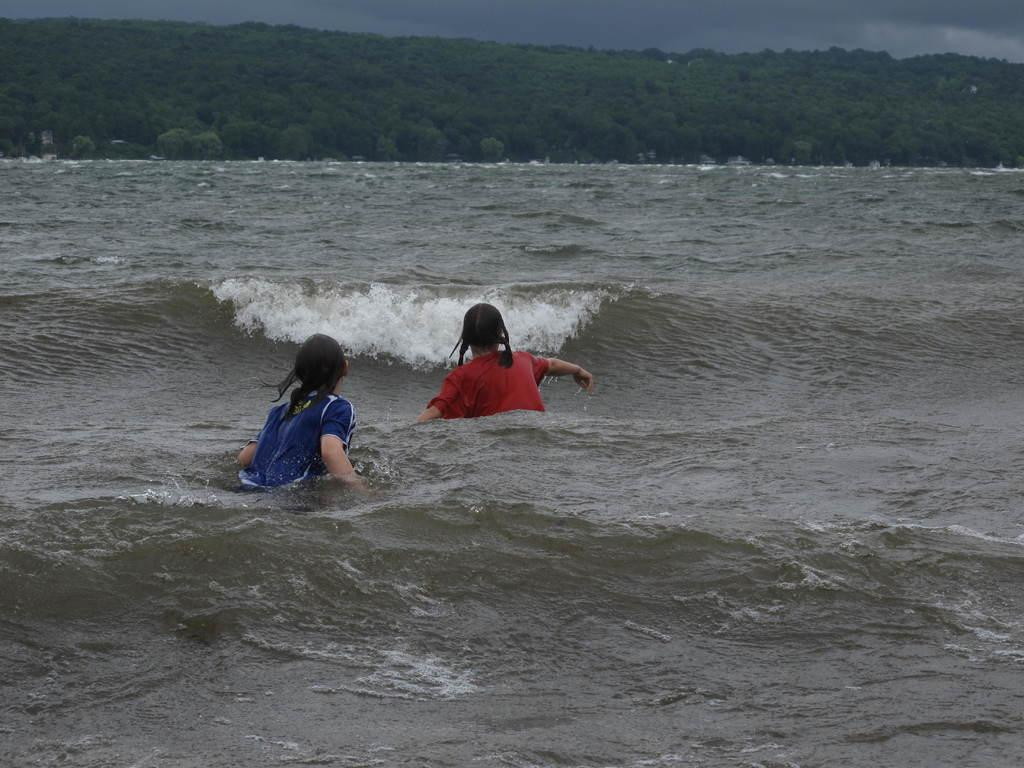How many women are in the water in the image? There are two women in the water in the image. What are the women doing in the water? The women are having tides in the water. What can be seen in the background of the image? There is a hill in the background of the image, and it has trees on it. What is visible at the top of the image? The sky is visible at the top of the image. What is the rate at which the women are skating in the image? The women are not skating in the image; they are having tides in the water. Can you tell me how many times the women turn during their activity in the image? There is no indication of the women turning during their activity in the image. 